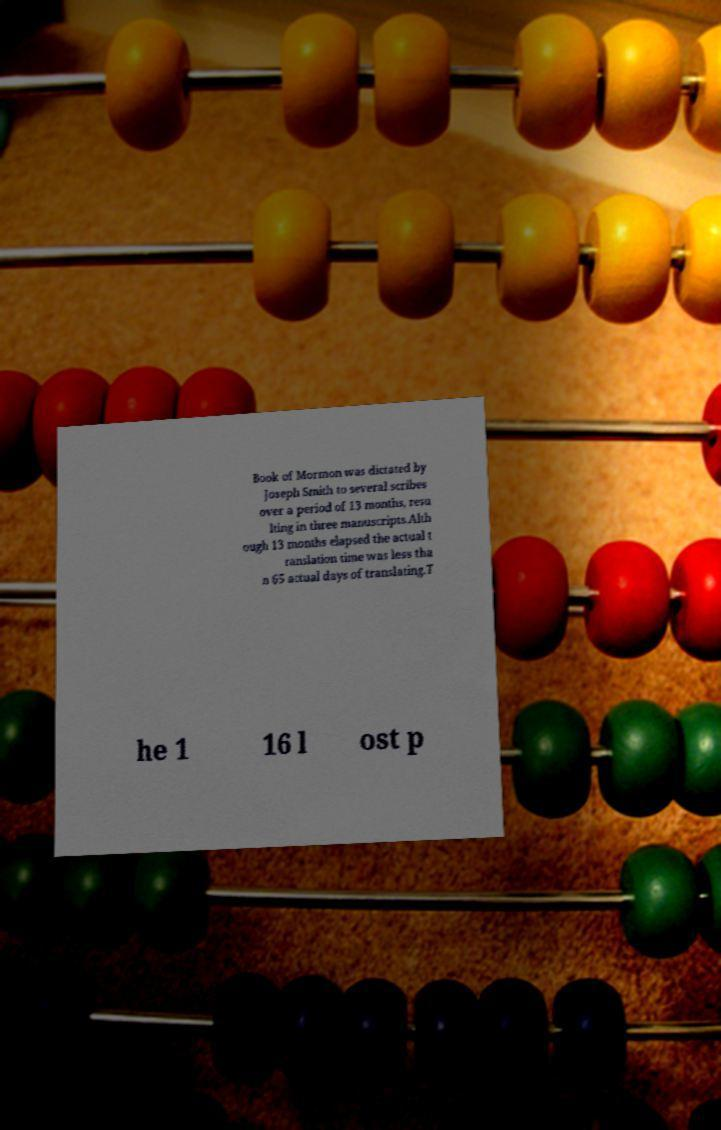Could you extract and type out the text from this image? Book of Mormon was dictated by Joseph Smith to several scribes over a period of 13 months, resu lting in three manuscripts.Alth ough 13 months elapsed the actual t ranslation time was less tha n 65 actual days of translating.T he 1 16 l ost p 